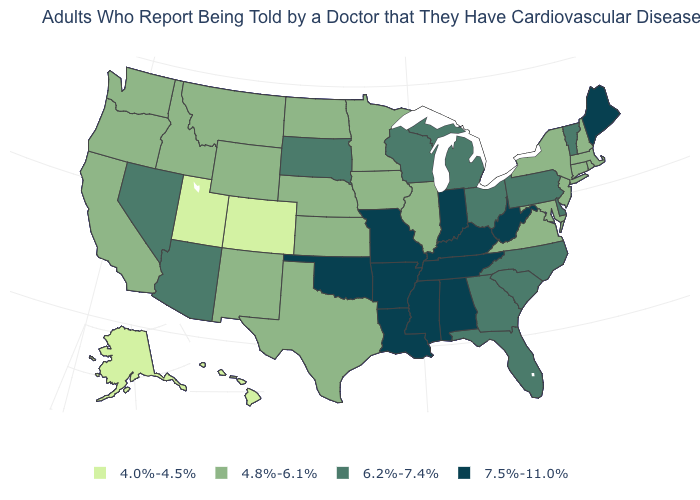Does Indiana have the highest value in the MidWest?
Keep it brief. Yes. How many symbols are there in the legend?
Quick response, please. 4. Which states hav the highest value in the West?
Keep it brief. Arizona, Nevada. Among the states that border Idaho , does Nevada have the highest value?
Quick response, please. Yes. Which states have the lowest value in the Northeast?
Answer briefly. Connecticut, Massachusetts, New Hampshire, New Jersey, New York, Rhode Island. How many symbols are there in the legend?
Concise answer only. 4. Among the states that border New Hampshire , does Maine have the highest value?
Give a very brief answer. Yes. Does Massachusetts have a lower value than Arkansas?
Be succinct. Yes. What is the value of Wyoming?
Keep it brief. 4.8%-6.1%. Which states have the lowest value in the West?
Be succinct. Alaska, Colorado, Hawaii, Utah. Does Alaska have the lowest value in the USA?
Give a very brief answer. Yes. How many symbols are there in the legend?
Be succinct. 4. Is the legend a continuous bar?
Keep it brief. No. Name the states that have a value in the range 7.5%-11.0%?
Be succinct. Alabama, Arkansas, Indiana, Kentucky, Louisiana, Maine, Mississippi, Missouri, Oklahoma, Tennessee, West Virginia. Which states have the lowest value in the Northeast?
Short answer required. Connecticut, Massachusetts, New Hampshire, New Jersey, New York, Rhode Island. 